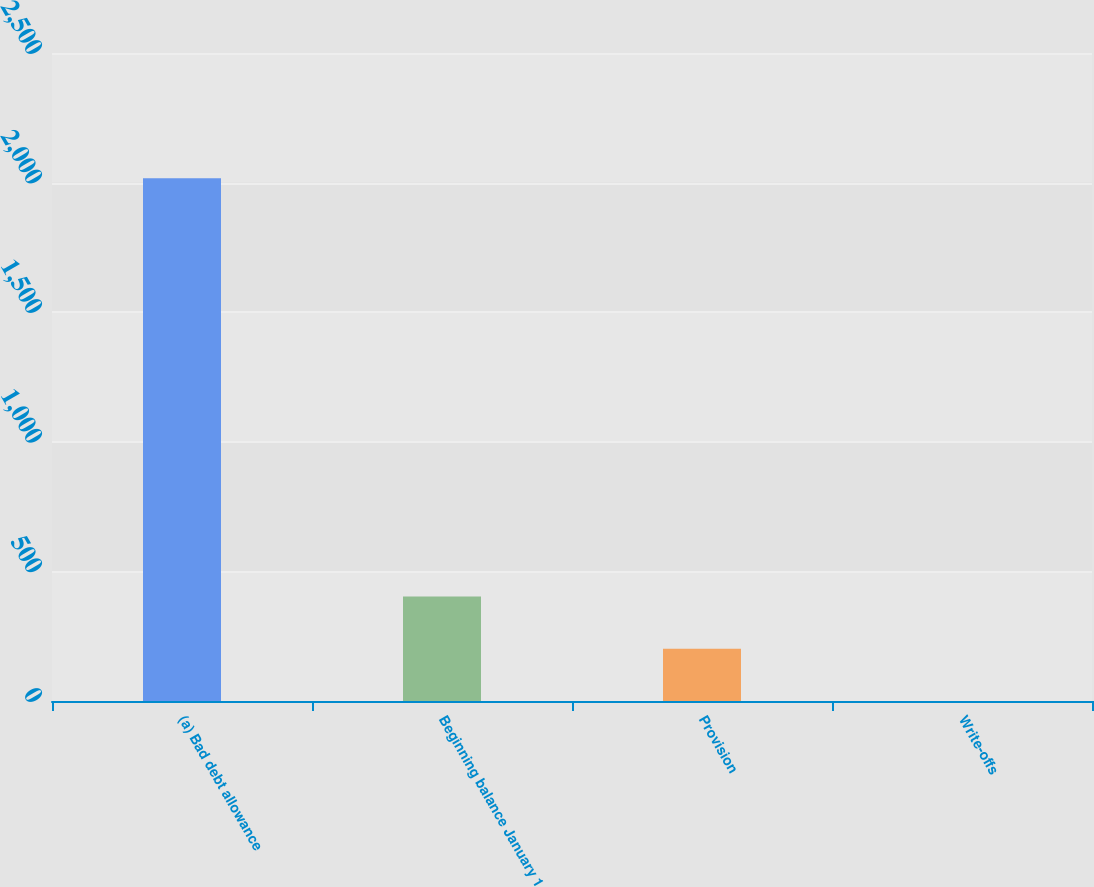<chart> <loc_0><loc_0><loc_500><loc_500><bar_chart><fcel>(a) Bad debt allowance<fcel>Beginning balance January 1<fcel>Provision<fcel>Write-offs<nl><fcel>2017<fcel>403.48<fcel>201.79<fcel>0.1<nl></chart> 